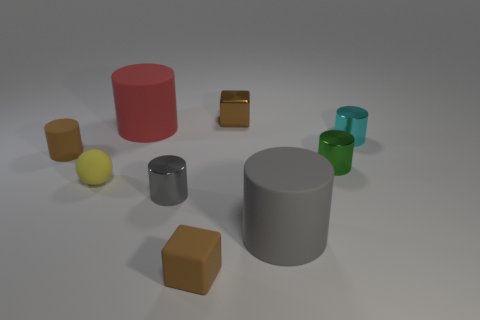Subtract all small rubber cylinders. How many cylinders are left? 5 Subtract all purple blocks. How many gray cylinders are left? 2 Subtract all green cylinders. How many cylinders are left? 5 Subtract 1 cylinders. How many cylinders are left? 5 Subtract 0 gray blocks. How many objects are left? 9 Subtract all spheres. How many objects are left? 8 Subtract all red cubes. Subtract all yellow balls. How many cubes are left? 2 Subtract all tiny green metallic objects. Subtract all tiny yellow rubber objects. How many objects are left? 7 Add 3 tiny brown cubes. How many tiny brown cubes are left? 5 Add 6 purple objects. How many purple objects exist? 6 